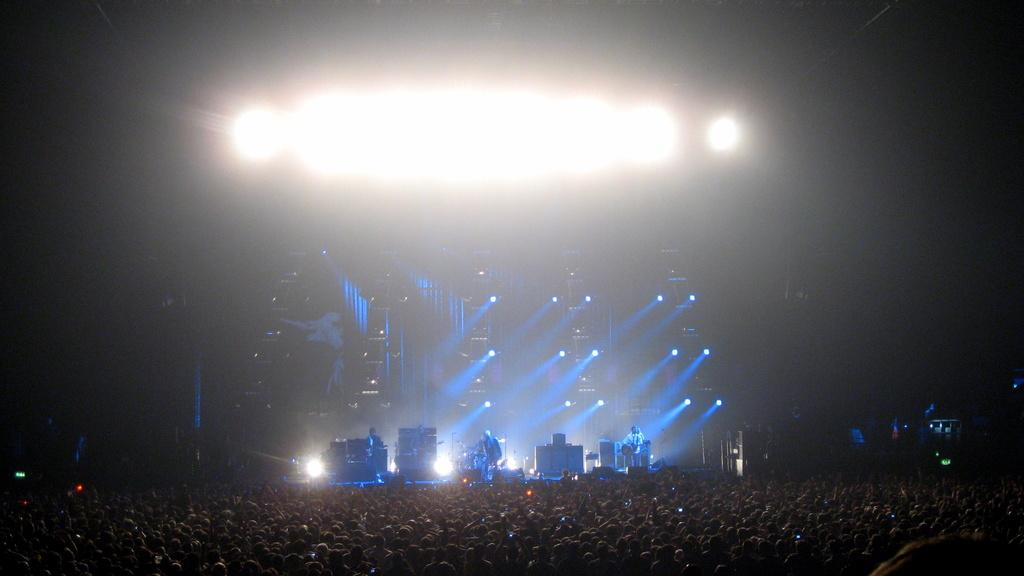What is happening in the foreground of the image? There are people in the foreground of the image. What activity is taking place in the background of the image? There are people playing musical instruments in the background of the image. What can be seen illuminated in the image? There are lights visible in the image. What type of mouth can be seen on the person playing the guitar in the image? There is no specific mouth visible on a person playing a guitar in the image, as the focus is on the musical instruments being played. 